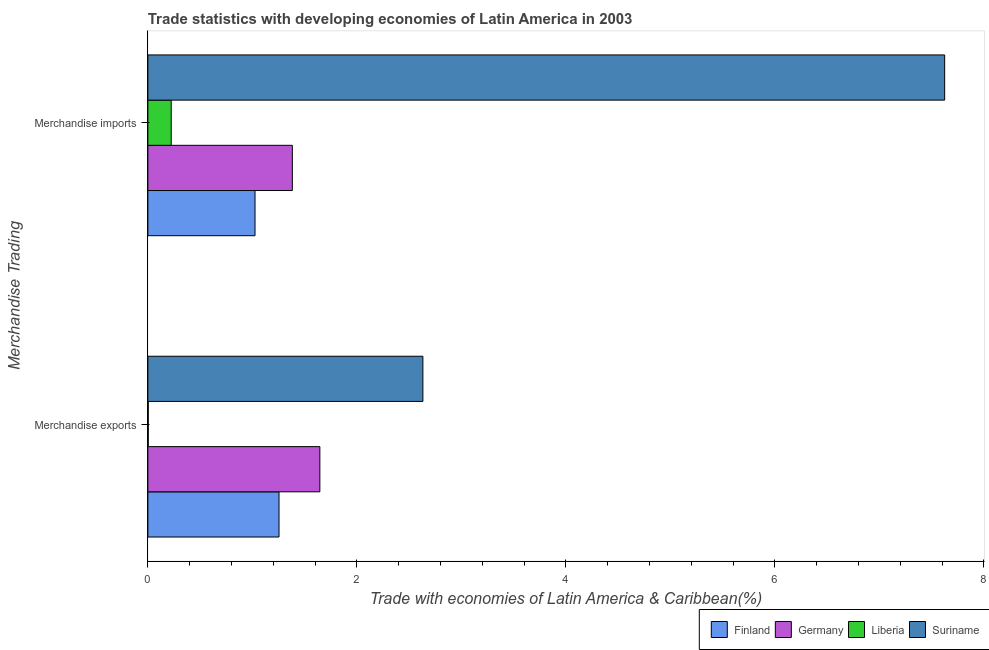How many different coloured bars are there?
Give a very brief answer. 4. How many groups of bars are there?
Give a very brief answer. 2. Are the number of bars per tick equal to the number of legend labels?
Your answer should be very brief. Yes. Are the number of bars on each tick of the Y-axis equal?
Offer a terse response. Yes. How many bars are there on the 1st tick from the bottom?
Provide a succinct answer. 4. What is the merchandise imports in Liberia?
Offer a terse response. 0.22. Across all countries, what is the maximum merchandise imports?
Your response must be concise. 7.62. Across all countries, what is the minimum merchandise exports?
Give a very brief answer. 0. In which country was the merchandise exports maximum?
Keep it short and to the point. Suriname. In which country was the merchandise exports minimum?
Ensure brevity in your answer.  Liberia. What is the total merchandise imports in the graph?
Provide a succinct answer. 10.25. What is the difference between the merchandise exports in Finland and that in Germany?
Give a very brief answer. -0.39. What is the difference between the merchandise imports in Suriname and the merchandise exports in Liberia?
Offer a very short reply. 7.62. What is the average merchandise exports per country?
Offer a terse response. 1.38. What is the difference between the merchandise imports and merchandise exports in Suriname?
Give a very brief answer. 4.99. In how many countries, is the merchandise exports greater than 7.6 %?
Your answer should be compact. 0. What is the ratio of the merchandise exports in Suriname to that in Germany?
Your response must be concise. 1.6. Is the merchandise exports in Germany less than that in Suriname?
Give a very brief answer. Yes. What does the 2nd bar from the top in Merchandise imports represents?
Make the answer very short. Liberia. What does the 1st bar from the bottom in Merchandise imports represents?
Ensure brevity in your answer.  Finland. How many bars are there?
Provide a short and direct response. 8. Are all the bars in the graph horizontal?
Keep it short and to the point. Yes. How many countries are there in the graph?
Give a very brief answer. 4. What is the difference between two consecutive major ticks on the X-axis?
Offer a terse response. 2. Are the values on the major ticks of X-axis written in scientific E-notation?
Your answer should be very brief. No. Does the graph contain grids?
Ensure brevity in your answer.  No. Where does the legend appear in the graph?
Your answer should be compact. Bottom right. How many legend labels are there?
Keep it short and to the point. 4. How are the legend labels stacked?
Provide a short and direct response. Horizontal. What is the title of the graph?
Provide a succinct answer. Trade statistics with developing economies of Latin America in 2003. Does "Comoros" appear as one of the legend labels in the graph?
Make the answer very short. No. What is the label or title of the X-axis?
Offer a terse response. Trade with economies of Latin America & Caribbean(%). What is the label or title of the Y-axis?
Your response must be concise. Merchandise Trading. What is the Trade with economies of Latin America & Caribbean(%) of Finland in Merchandise exports?
Offer a terse response. 1.25. What is the Trade with economies of Latin America & Caribbean(%) in Germany in Merchandise exports?
Ensure brevity in your answer.  1.65. What is the Trade with economies of Latin America & Caribbean(%) in Liberia in Merchandise exports?
Give a very brief answer. 0. What is the Trade with economies of Latin America & Caribbean(%) in Suriname in Merchandise exports?
Keep it short and to the point. 2.63. What is the Trade with economies of Latin America & Caribbean(%) of Finland in Merchandise imports?
Offer a terse response. 1.03. What is the Trade with economies of Latin America & Caribbean(%) in Germany in Merchandise imports?
Offer a very short reply. 1.38. What is the Trade with economies of Latin America & Caribbean(%) of Liberia in Merchandise imports?
Offer a terse response. 0.22. What is the Trade with economies of Latin America & Caribbean(%) of Suriname in Merchandise imports?
Give a very brief answer. 7.62. Across all Merchandise Trading, what is the maximum Trade with economies of Latin America & Caribbean(%) in Finland?
Make the answer very short. 1.25. Across all Merchandise Trading, what is the maximum Trade with economies of Latin America & Caribbean(%) in Germany?
Offer a very short reply. 1.65. Across all Merchandise Trading, what is the maximum Trade with economies of Latin America & Caribbean(%) of Liberia?
Your response must be concise. 0.22. Across all Merchandise Trading, what is the maximum Trade with economies of Latin America & Caribbean(%) of Suriname?
Provide a succinct answer. 7.62. Across all Merchandise Trading, what is the minimum Trade with economies of Latin America & Caribbean(%) of Finland?
Provide a succinct answer. 1.03. Across all Merchandise Trading, what is the minimum Trade with economies of Latin America & Caribbean(%) of Germany?
Provide a short and direct response. 1.38. Across all Merchandise Trading, what is the minimum Trade with economies of Latin America & Caribbean(%) in Liberia?
Offer a terse response. 0. Across all Merchandise Trading, what is the minimum Trade with economies of Latin America & Caribbean(%) in Suriname?
Your answer should be compact. 2.63. What is the total Trade with economies of Latin America & Caribbean(%) of Finland in the graph?
Ensure brevity in your answer.  2.28. What is the total Trade with economies of Latin America & Caribbean(%) in Germany in the graph?
Keep it short and to the point. 3.03. What is the total Trade with economies of Latin America & Caribbean(%) of Liberia in the graph?
Your answer should be compact. 0.23. What is the total Trade with economies of Latin America & Caribbean(%) in Suriname in the graph?
Your response must be concise. 10.26. What is the difference between the Trade with economies of Latin America & Caribbean(%) of Finland in Merchandise exports and that in Merchandise imports?
Your answer should be compact. 0.23. What is the difference between the Trade with economies of Latin America & Caribbean(%) of Germany in Merchandise exports and that in Merchandise imports?
Offer a very short reply. 0.26. What is the difference between the Trade with economies of Latin America & Caribbean(%) in Liberia in Merchandise exports and that in Merchandise imports?
Ensure brevity in your answer.  -0.22. What is the difference between the Trade with economies of Latin America & Caribbean(%) of Suriname in Merchandise exports and that in Merchandise imports?
Your answer should be very brief. -4.99. What is the difference between the Trade with economies of Latin America & Caribbean(%) in Finland in Merchandise exports and the Trade with economies of Latin America & Caribbean(%) in Germany in Merchandise imports?
Your response must be concise. -0.13. What is the difference between the Trade with economies of Latin America & Caribbean(%) in Finland in Merchandise exports and the Trade with economies of Latin America & Caribbean(%) in Liberia in Merchandise imports?
Make the answer very short. 1.03. What is the difference between the Trade with economies of Latin America & Caribbean(%) of Finland in Merchandise exports and the Trade with economies of Latin America & Caribbean(%) of Suriname in Merchandise imports?
Make the answer very short. -6.37. What is the difference between the Trade with economies of Latin America & Caribbean(%) of Germany in Merchandise exports and the Trade with economies of Latin America & Caribbean(%) of Liberia in Merchandise imports?
Your answer should be very brief. 1.42. What is the difference between the Trade with economies of Latin America & Caribbean(%) in Germany in Merchandise exports and the Trade with economies of Latin America & Caribbean(%) in Suriname in Merchandise imports?
Your answer should be very brief. -5.98. What is the difference between the Trade with economies of Latin America & Caribbean(%) of Liberia in Merchandise exports and the Trade with economies of Latin America & Caribbean(%) of Suriname in Merchandise imports?
Your answer should be very brief. -7.62. What is the average Trade with economies of Latin America & Caribbean(%) in Finland per Merchandise Trading?
Your answer should be compact. 1.14. What is the average Trade with economies of Latin America & Caribbean(%) of Germany per Merchandise Trading?
Offer a very short reply. 1.51. What is the average Trade with economies of Latin America & Caribbean(%) of Liberia per Merchandise Trading?
Ensure brevity in your answer.  0.11. What is the average Trade with economies of Latin America & Caribbean(%) in Suriname per Merchandise Trading?
Keep it short and to the point. 5.13. What is the difference between the Trade with economies of Latin America & Caribbean(%) in Finland and Trade with economies of Latin America & Caribbean(%) in Germany in Merchandise exports?
Give a very brief answer. -0.39. What is the difference between the Trade with economies of Latin America & Caribbean(%) in Finland and Trade with economies of Latin America & Caribbean(%) in Liberia in Merchandise exports?
Provide a short and direct response. 1.25. What is the difference between the Trade with economies of Latin America & Caribbean(%) in Finland and Trade with economies of Latin America & Caribbean(%) in Suriname in Merchandise exports?
Offer a terse response. -1.38. What is the difference between the Trade with economies of Latin America & Caribbean(%) in Germany and Trade with economies of Latin America & Caribbean(%) in Liberia in Merchandise exports?
Your answer should be compact. 1.64. What is the difference between the Trade with economies of Latin America & Caribbean(%) of Germany and Trade with economies of Latin America & Caribbean(%) of Suriname in Merchandise exports?
Ensure brevity in your answer.  -0.99. What is the difference between the Trade with economies of Latin America & Caribbean(%) of Liberia and Trade with economies of Latin America & Caribbean(%) of Suriname in Merchandise exports?
Offer a very short reply. -2.63. What is the difference between the Trade with economies of Latin America & Caribbean(%) in Finland and Trade with economies of Latin America & Caribbean(%) in Germany in Merchandise imports?
Your response must be concise. -0.36. What is the difference between the Trade with economies of Latin America & Caribbean(%) of Finland and Trade with economies of Latin America & Caribbean(%) of Liberia in Merchandise imports?
Provide a succinct answer. 0.8. What is the difference between the Trade with economies of Latin America & Caribbean(%) in Finland and Trade with economies of Latin America & Caribbean(%) in Suriname in Merchandise imports?
Your response must be concise. -6.6. What is the difference between the Trade with economies of Latin America & Caribbean(%) of Germany and Trade with economies of Latin America & Caribbean(%) of Liberia in Merchandise imports?
Give a very brief answer. 1.16. What is the difference between the Trade with economies of Latin America & Caribbean(%) in Germany and Trade with economies of Latin America & Caribbean(%) in Suriname in Merchandise imports?
Your response must be concise. -6.24. What is the difference between the Trade with economies of Latin America & Caribbean(%) of Liberia and Trade with economies of Latin America & Caribbean(%) of Suriname in Merchandise imports?
Give a very brief answer. -7.4. What is the ratio of the Trade with economies of Latin America & Caribbean(%) of Finland in Merchandise exports to that in Merchandise imports?
Offer a terse response. 1.22. What is the ratio of the Trade with economies of Latin America & Caribbean(%) in Germany in Merchandise exports to that in Merchandise imports?
Ensure brevity in your answer.  1.19. What is the ratio of the Trade with economies of Latin America & Caribbean(%) in Liberia in Merchandise exports to that in Merchandise imports?
Your answer should be very brief. 0.02. What is the ratio of the Trade with economies of Latin America & Caribbean(%) in Suriname in Merchandise exports to that in Merchandise imports?
Your answer should be compact. 0.35. What is the difference between the highest and the second highest Trade with economies of Latin America & Caribbean(%) of Finland?
Make the answer very short. 0.23. What is the difference between the highest and the second highest Trade with economies of Latin America & Caribbean(%) of Germany?
Give a very brief answer. 0.26. What is the difference between the highest and the second highest Trade with economies of Latin America & Caribbean(%) of Liberia?
Provide a short and direct response. 0.22. What is the difference between the highest and the second highest Trade with economies of Latin America & Caribbean(%) of Suriname?
Keep it short and to the point. 4.99. What is the difference between the highest and the lowest Trade with economies of Latin America & Caribbean(%) of Finland?
Your answer should be compact. 0.23. What is the difference between the highest and the lowest Trade with economies of Latin America & Caribbean(%) of Germany?
Provide a succinct answer. 0.26. What is the difference between the highest and the lowest Trade with economies of Latin America & Caribbean(%) of Liberia?
Your answer should be very brief. 0.22. What is the difference between the highest and the lowest Trade with economies of Latin America & Caribbean(%) of Suriname?
Offer a terse response. 4.99. 